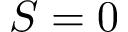<formula> <loc_0><loc_0><loc_500><loc_500>S = 0</formula> 